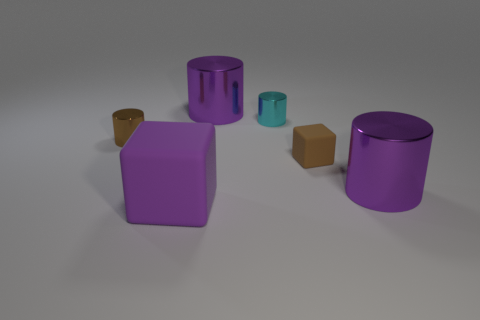There is a brown thing that is the same material as the small cyan thing; what size is it?
Make the answer very short. Small. How many rubber objects have the same size as the brown shiny thing?
Offer a terse response. 1. The metal cylinder that is the same color as the tiny block is what size?
Provide a short and direct response. Small. The shiny thing that is to the left of the big purple object that is behind the brown shiny cylinder is what color?
Give a very brief answer. Brown. Are there any metallic cylinders that have the same color as the small rubber thing?
Your response must be concise. Yes. What is the color of the metal thing that is the same size as the cyan metal cylinder?
Provide a short and direct response. Brown. Do the small brown object that is behind the small brown rubber block and the tiny cyan cylinder have the same material?
Make the answer very short. Yes. There is a big purple cylinder to the left of the large purple cylinder that is in front of the tiny matte cube; is there a tiny brown cylinder to the right of it?
Give a very brief answer. No. Does the thing that is to the left of the big block have the same shape as the cyan shiny thing?
Your answer should be compact. Yes. What shape is the purple shiny thing that is behind the big object on the right side of the cyan object?
Provide a short and direct response. Cylinder. 